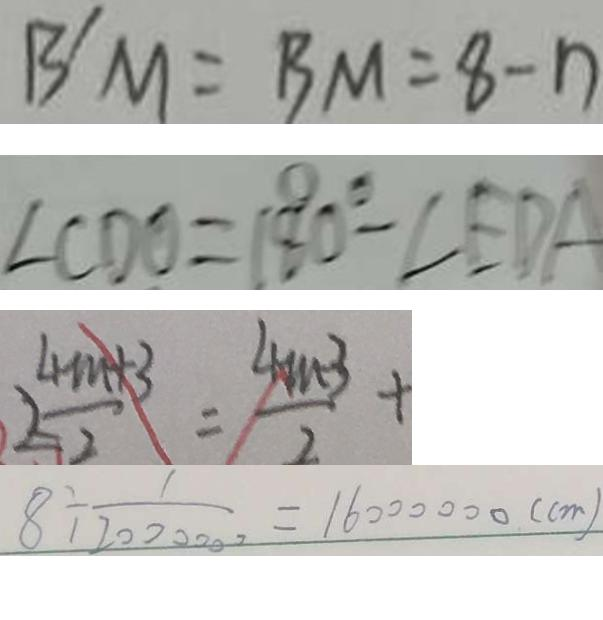<formula> <loc_0><loc_0><loc_500><loc_500>B ^ { \prime } M = B M = 8 - n 
 \angle C D O = ( 1 8 0 ^ { \circ } - \angle E D A 
 \frac { 4 m + 3 } { 2 } = \frac { 4 n + 3 } { 2 } + 
 8 \div \frac { 1 } { 2 0 0 0 0 0 0 } = 1 6 0 0 0 0 0 0 ( c m )</formula> 